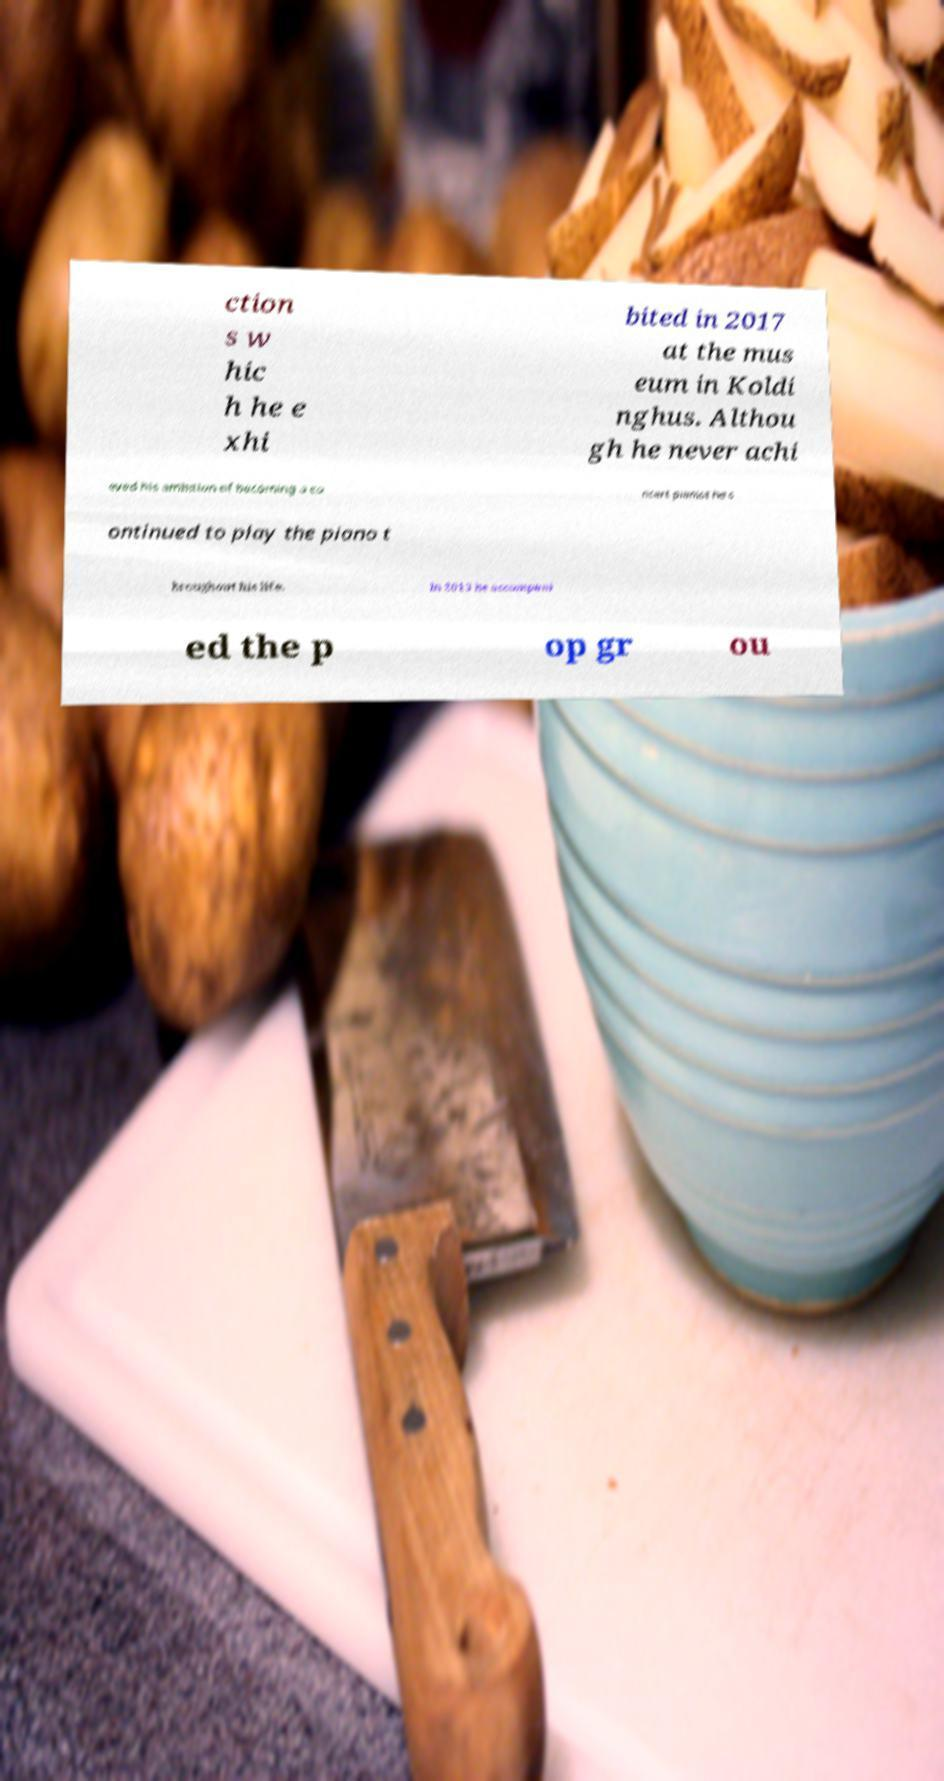There's text embedded in this image that I need extracted. Can you transcribe it verbatim? ction s w hic h he e xhi bited in 2017 at the mus eum in Koldi nghus. Althou gh he never achi eved his ambition of becoming a co ncert pianist he c ontinued to play the piano t hroughout his life. In 2013 he accompani ed the p op gr ou 